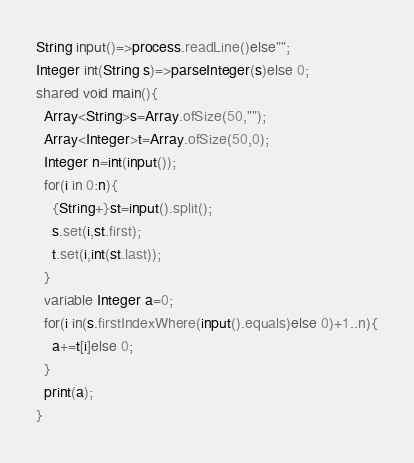Convert code to text. <code><loc_0><loc_0><loc_500><loc_500><_Ceylon_>String input()=>process.readLine()else""; 
Integer int(String s)=>parseInteger(s)else 0;
shared void main(){
  Array<String>s=Array.ofSize(50,"");
  Array<Integer>t=Array.ofSize(50,0);
  Integer n=int(input());
  for(i in 0:n){
    {String+}st=input().split();
    s.set(i,st.first);
    t.set(i,int(st.last));
  }
  variable Integer a=0;
  for(i in(s.firstIndexWhere(input().equals)else 0)+1..n){
    a+=t[i]else 0;
  }
  print(a);
}
</code> 